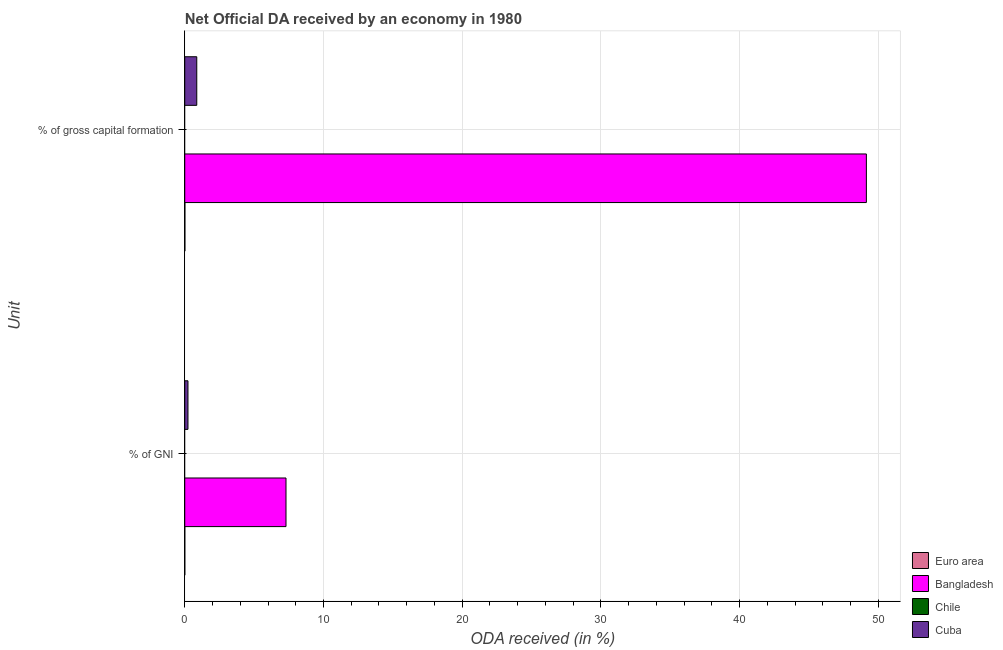How many different coloured bars are there?
Your answer should be compact. 3. How many groups of bars are there?
Provide a short and direct response. 2. Are the number of bars per tick equal to the number of legend labels?
Offer a very short reply. No. How many bars are there on the 1st tick from the top?
Offer a terse response. 3. What is the label of the 1st group of bars from the top?
Provide a short and direct response. % of gross capital formation. What is the oda received as percentage of gross capital formation in Bangladesh?
Provide a short and direct response. 49.13. Across all countries, what is the maximum oda received as percentage of gross capital formation?
Provide a succinct answer. 49.13. Across all countries, what is the minimum oda received as percentage of gni?
Provide a succinct answer. 0. What is the total oda received as percentage of gni in the graph?
Provide a short and direct response. 7.53. What is the difference between the oda received as percentage of gross capital formation in Bangladesh and that in Euro area?
Keep it short and to the point. 49.12. What is the difference between the oda received as percentage of gni in Cuba and the oda received as percentage of gross capital formation in Euro area?
Your response must be concise. 0.22. What is the average oda received as percentage of gni per country?
Your response must be concise. 1.88. What is the difference between the oda received as percentage of gross capital formation and oda received as percentage of gni in Euro area?
Offer a terse response. 0.01. What is the ratio of the oda received as percentage of gross capital formation in Cuba to that in Euro area?
Your answer should be very brief. 98.58. Is the oda received as percentage of gross capital formation in Euro area less than that in Cuba?
Give a very brief answer. Yes. How many bars are there?
Give a very brief answer. 6. How many countries are there in the graph?
Provide a succinct answer. 4. Where does the legend appear in the graph?
Keep it short and to the point. Bottom right. How many legend labels are there?
Provide a short and direct response. 4. How are the legend labels stacked?
Your response must be concise. Vertical. What is the title of the graph?
Offer a terse response. Net Official DA received by an economy in 1980. Does "World" appear as one of the legend labels in the graph?
Offer a terse response. No. What is the label or title of the X-axis?
Make the answer very short. ODA received (in %). What is the label or title of the Y-axis?
Provide a short and direct response. Unit. What is the ODA received (in %) of Euro area in % of GNI?
Keep it short and to the point. 0. What is the ODA received (in %) in Bangladesh in % of GNI?
Give a very brief answer. 7.3. What is the ODA received (in %) in Cuba in % of GNI?
Your answer should be very brief. 0.23. What is the ODA received (in %) in Euro area in % of gross capital formation?
Your answer should be compact. 0.01. What is the ODA received (in %) in Bangladesh in % of gross capital formation?
Provide a succinct answer. 49.13. What is the ODA received (in %) of Cuba in % of gross capital formation?
Your response must be concise. 0.87. Across all Unit, what is the maximum ODA received (in %) of Euro area?
Provide a succinct answer. 0.01. Across all Unit, what is the maximum ODA received (in %) in Bangladesh?
Make the answer very short. 49.13. Across all Unit, what is the maximum ODA received (in %) of Cuba?
Provide a succinct answer. 0.87. Across all Unit, what is the minimum ODA received (in %) in Euro area?
Give a very brief answer. 0. Across all Unit, what is the minimum ODA received (in %) in Bangladesh?
Ensure brevity in your answer.  7.3. Across all Unit, what is the minimum ODA received (in %) in Cuba?
Offer a terse response. 0.23. What is the total ODA received (in %) in Euro area in the graph?
Provide a short and direct response. 0.01. What is the total ODA received (in %) in Bangladesh in the graph?
Your answer should be compact. 56.43. What is the total ODA received (in %) in Cuba in the graph?
Provide a short and direct response. 1.1. What is the difference between the ODA received (in %) of Euro area in % of GNI and that in % of gross capital formation?
Keep it short and to the point. -0.01. What is the difference between the ODA received (in %) in Bangladesh in % of GNI and that in % of gross capital formation?
Provide a succinct answer. -41.83. What is the difference between the ODA received (in %) of Cuba in % of GNI and that in % of gross capital formation?
Provide a short and direct response. -0.63. What is the difference between the ODA received (in %) of Euro area in % of GNI and the ODA received (in %) of Bangladesh in % of gross capital formation?
Offer a very short reply. -49.13. What is the difference between the ODA received (in %) of Euro area in % of GNI and the ODA received (in %) of Cuba in % of gross capital formation?
Keep it short and to the point. -0.86. What is the difference between the ODA received (in %) in Bangladesh in % of GNI and the ODA received (in %) in Cuba in % of gross capital formation?
Provide a succinct answer. 6.43. What is the average ODA received (in %) of Euro area per Unit?
Make the answer very short. 0.01. What is the average ODA received (in %) in Bangladesh per Unit?
Give a very brief answer. 28.21. What is the average ODA received (in %) of Cuba per Unit?
Your answer should be very brief. 0.55. What is the difference between the ODA received (in %) of Euro area and ODA received (in %) of Bangladesh in % of GNI?
Give a very brief answer. -7.3. What is the difference between the ODA received (in %) of Euro area and ODA received (in %) of Cuba in % of GNI?
Your answer should be very brief. -0.23. What is the difference between the ODA received (in %) in Bangladesh and ODA received (in %) in Cuba in % of GNI?
Ensure brevity in your answer.  7.07. What is the difference between the ODA received (in %) of Euro area and ODA received (in %) of Bangladesh in % of gross capital formation?
Keep it short and to the point. -49.12. What is the difference between the ODA received (in %) of Euro area and ODA received (in %) of Cuba in % of gross capital formation?
Your answer should be very brief. -0.86. What is the difference between the ODA received (in %) in Bangladesh and ODA received (in %) in Cuba in % of gross capital formation?
Give a very brief answer. 48.26. What is the ratio of the ODA received (in %) of Euro area in % of GNI to that in % of gross capital formation?
Ensure brevity in your answer.  0.26. What is the ratio of the ODA received (in %) in Bangladesh in % of GNI to that in % of gross capital formation?
Keep it short and to the point. 0.15. What is the ratio of the ODA received (in %) of Cuba in % of GNI to that in % of gross capital formation?
Ensure brevity in your answer.  0.27. What is the difference between the highest and the second highest ODA received (in %) in Euro area?
Keep it short and to the point. 0.01. What is the difference between the highest and the second highest ODA received (in %) in Bangladesh?
Your response must be concise. 41.83. What is the difference between the highest and the second highest ODA received (in %) of Cuba?
Offer a terse response. 0.63. What is the difference between the highest and the lowest ODA received (in %) of Euro area?
Give a very brief answer. 0.01. What is the difference between the highest and the lowest ODA received (in %) in Bangladesh?
Give a very brief answer. 41.83. What is the difference between the highest and the lowest ODA received (in %) in Cuba?
Your answer should be compact. 0.63. 